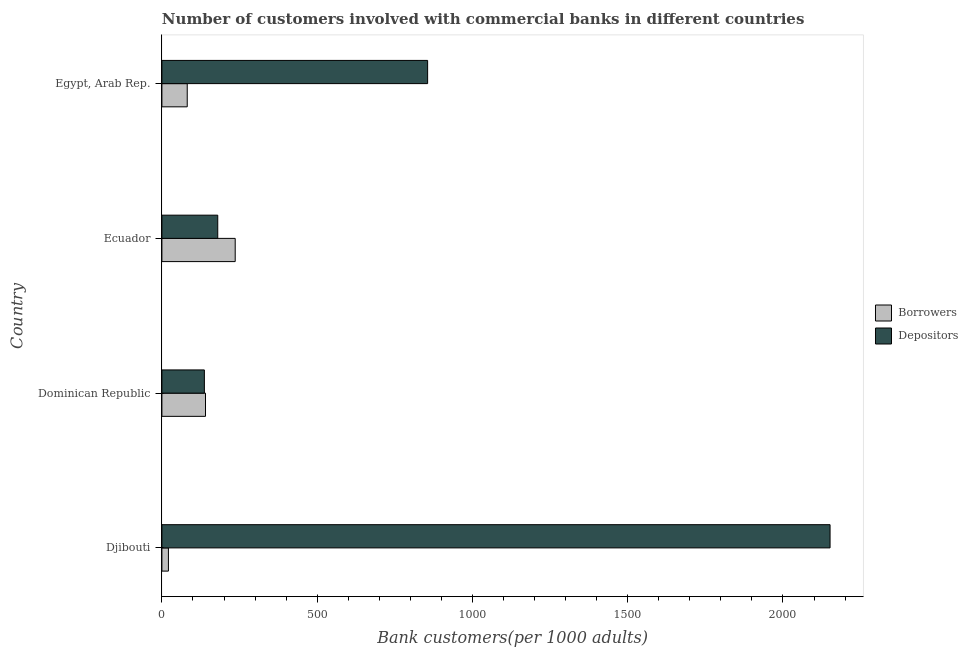How many different coloured bars are there?
Ensure brevity in your answer.  2. How many groups of bars are there?
Ensure brevity in your answer.  4. Are the number of bars per tick equal to the number of legend labels?
Your answer should be compact. Yes. How many bars are there on the 2nd tick from the bottom?
Provide a succinct answer. 2. What is the label of the 4th group of bars from the top?
Provide a short and direct response. Djibouti. What is the number of depositors in Djibouti?
Give a very brief answer. 2151.67. Across all countries, what is the maximum number of borrowers?
Offer a terse response. 236.05. Across all countries, what is the minimum number of depositors?
Your answer should be very brief. 136.78. In which country was the number of depositors maximum?
Your response must be concise. Djibouti. In which country was the number of depositors minimum?
Provide a short and direct response. Dominican Republic. What is the total number of depositors in the graph?
Your response must be concise. 3324.01. What is the difference between the number of depositors in Dominican Republic and that in Egypt, Arab Rep.?
Keep it short and to the point. -718.93. What is the difference between the number of borrowers in Egypt, Arab Rep. and the number of depositors in Djibouti?
Provide a succinct answer. -2070.06. What is the average number of borrowers per country?
Provide a succinct answer. 119.76. What is the difference between the number of depositors and number of borrowers in Dominican Republic?
Your answer should be compact. -3.61. In how many countries, is the number of depositors greater than 1500 ?
Give a very brief answer. 1. What is the ratio of the number of borrowers in Dominican Republic to that in Ecuador?
Give a very brief answer. 0.59. What is the difference between the highest and the second highest number of depositors?
Your answer should be very brief. 1295.95. What is the difference between the highest and the lowest number of depositors?
Offer a terse response. 2014.88. In how many countries, is the number of depositors greater than the average number of depositors taken over all countries?
Provide a succinct answer. 2. Is the sum of the number of borrowers in Djibouti and Ecuador greater than the maximum number of depositors across all countries?
Offer a very short reply. No. What does the 2nd bar from the top in Ecuador represents?
Keep it short and to the point. Borrowers. What does the 1st bar from the bottom in Dominican Republic represents?
Offer a very short reply. Borrowers. How many bars are there?
Provide a succinct answer. 8. Are all the bars in the graph horizontal?
Make the answer very short. Yes. How many countries are there in the graph?
Give a very brief answer. 4. Are the values on the major ticks of X-axis written in scientific E-notation?
Make the answer very short. No. Does the graph contain grids?
Make the answer very short. No. Where does the legend appear in the graph?
Keep it short and to the point. Center right. How many legend labels are there?
Your answer should be compact. 2. What is the title of the graph?
Ensure brevity in your answer.  Number of customers involved with commercial banks in different countries. What is the label or title of the X-axis?
Keep it short and to the point. Bank customers(per 1000 adults). What is the Bank customers(per 1000 adults) in Borrowers in Djibouti?
Give a very brief answer. 20.98. What is the Bank customers(per 1000 adults) of Depositors in Djibouti?
Ensure brevity in your answer.  2151.67. What is the Bank customers(per 1000 adults) of Borrowers in Dominican Republic?
Provide a short and direct response. 140.39. What is the Bank customers(per 1000 adults) in Depositors in Dominican Republic?
Your response must be concise. 136.78. What is the Bank customers(per 1000 adults) in Borrowers in Ecuador?
Your answer should be compact. 236.05. What is the Bank customers(per 1000 adults) in Depositors in Ecuador?
Make the answer very short. 179.84. What is the Bank customers(per 1000 adults) in Borrowers in Egypt, Arab Rep.?
Give a very brief answer. 81.61. What is the Bank customers(per 1000 adults) of Depositors in Egypt, Arab Rep.?
Offer a very short reply. 855.71. Across all countries, what is the maximum Bank customers(per 1000 adults) of Borrowers?
Offer a very short reply. 236.05. Across all countries, what is the maximum Bank customers(per 1000 adults) of Depositors?
Provide a succinct answer. 2151.67. Across all countries, what is the minimum Bank customers(per 1000 adults) in Borrowers?
Offer a terse response. 20.98. Across all countries, what is the minimum Bank customers(per 1000 adults) in Depositors?
Your answer should be compact. 136.78. What is the total Bank customers(per 1000 adults) in Borrowers in the graph?
Your answer should be very brief. 479.03. What is the total Bank customers(per 1000 adults) of Depositors in the graph?
Provide a succinct answer. 3324.01. What is the difference between the Bank customers(per 1000 adults) of Borrowers in Djibouti and that in Dominican Republic?
Your answer should be compact. -119.41. What is the difference between the Bank customers(per 1000 adults) in Depositors in Djibouti and that in Dominican Republic?
Keep it short and to the point. 2014.88. What is the difference between the Bank customers(per 1000 adults) in Borrowers in Djibouti and that in Ecuador?
Ensure brevity in your answer.  -215.07. What is the difference between the Bank customers(per 1000 adults) of Depositors in Djibouti and that in Ecuador?
Your answer should be compact. 1971.83. What is the difference between the Bank customers(per 1000 adults) of Borrowers in Djibouti and that in Egypt, Arab Rep.?
Ensure brevity in your answer.  -60.63. What is the difference between the Bank customers(per 1000 adults) in Depositors in Djibouti and that in Egypt, Arab Rep.?
Keep it short and to the point. 1295.96. What is the difference between the Bank customers(per 1000 adults) in Borrowers in Dominican Republic and that in Ecuador?
Provide a succinct answer. -95.66. What is the difference between the Bank customers(per 1000 adults) of Depositors in Dominican Republic and that in Ecuador?
Your answer should be very brief. -43.06. What is the difference between the Bank customers(per 1000 adults) of Borrowers in Dominican Republic and that in Egypt, Arab Rep.?
Give a very brief answer. 58.78. What is the difference between the Bank customers(per 1000 adults) of Depositors in Dominican Republic and that in Egypt, Arab Rep.?
Your response must be concise. -718.93. What is the difference between the Bank customers(per 1000 adults) in Borrowers in Ecuador and that in Egypt, Arab Rep.?
Offer a very short reply. 154.45. What is the difference between the Bank customers(per 1000 adults) of Depositors in Ecuador and that in Egypt, Arab Rep.?
Provide a succinct answer. -675.87. What is the difference between the Bank customers(per 1000 adults) of Borrowers in Djibouti and the Bank customers(per 1000 adults) of Depositors in Dominican Republic?
Your answer should be compact. -115.81. What is the difference between the Bank customers(per 1000 adults) of Borrowers in Djibouti and the Bank customers(per 1000 adults) of Depositors in Ecuador?
Keep it short and to the point. -158.86. What is the difference between the Bank customers(per 1000 adults) of Borrowers in Djibouti and the Bank customers(per 1000 adults) of Depositors in Egypt, Arab Rep.?
Provide a short and direct response. -834.74. What is the difference between the Bank customers(per 1000 adults) in Borrowers in Dominican Republic and the Bank customers(per 1000 adults) in Depositors in Ecuador?
Offer a very short reply. -39.45. What is the difference between the Bank customers(per 1000 adults) in Borrowers in Dominican Republic and the Bank customers(per 1000 adults) in Depositors in Egypt, Arab Rep.?
Give a very brief answer. -715.32. What is the difference between the Bank customers(per 1000 adults) in Borrowers in Ecuador and the Bank customers(per 1000 adults) in Depositors in Egypt, Arab Rep.?
Offer a very short reply. -619.66. What is the average Bank customers(per 1000 adults) in Borrowers per country?
Offer a terse response. 119.76. What is the average Bank customers(per 1000 adults) of Depositors per country?
Your response must be concise. 831. What is the difference between the Bank customers(per 1000 adults) in Borrowers and Bank customers(per 1000 adults) in Depositors in Djibouti?
Your response must be concise. -2130.69. What is the difference between the Bank customers(per 1000 adults) in Borrowers and Bank customers(per 1000 adults) in Depositors in Dominican Republic?
Your answer should be very brief. 3.61. What is the difference between the Bank customers(per 1000 adults) of Borrowers and Bank customers(per 1000 adults) of Depositors in Ecuador?
Offer a very short reply. 56.21. What is the difference between the Bank customers(per 1000 adults) in Borrowers and Bank customers(per 1000 adults) in Depositors in Egypt, Arab Rep.?
Provide a succinct answer. -774.11. What is the ratio of the Bank customers(per 1000 adults) in Borrowers in Djibouti to that in Dominican Republic?
Offer a very short reply. 0.15. What is the ratio of the Bank customers(per 1000 adults) in Depositors in Djibouti to that in Dominican Republic?
Provide a short and direct response. 15.73. What is the ratio of the Bank customers(per 1000 adults) in Borrowers in Djibouti to that in Ecuador?
Ensure brevity in your answer.  0.09. What is the ratio of the Bank customers(per 1000 adults) of Depositors in Djibouti to that in Ecuador?
Provide a short and direct response. 11.96. What is the ratio of the Bank customers(per 1000 adults) in Borrowers in Djibouti to that in Egypt, Arab Rep.?
Your answer should be compact. 0.26. What is the ratio of the Bank customers(per 1000 adults) of Depositors in Djibouti to that in Egypt, Arab Rep.?
Make the answer very short. 2.51. What is the ratio of the Bank customers(per 1000 adults) in Borrowers in Dominican Republic to that in Ecuador?
Your answer should be very brief. 0.59. What is the ratio of the Bank customers(per 1000 adults) in Depositors in Dominican Republic to that in Ecuador?
Offer a very short reply. 0.76. What is the ratio of the Bank customers(per 1000 adults) in Borrowers in Dominican Republic to that in Egypt, Arab Rep.?
Make the answer very short. 1.72. What is the ratio of the Bank customers(per 1000 adults) in Depositors in Dominican Republic to that in Egypt, Arab Rep.?
Your response must be concise. 0.16. What is the ratio of the Bank customers(per 1000 adults) in Borrowers in Ecuador to that in Egypt, Arab Rep.?
Ensure brevity in your answer.  2.89. What is the ratio of the Bank customers(per 1000 adults) of Depositors in Ecuador to that in Egypt, Arab Rep.?
Your answer should be very brief. 0.21. What is the difference between the highest and the second highest Bank customers(per 1000 adults) of Borrowers?
Your answer should be very brief. 95.66. What is the difference between the highest and the second highest Bank customers(per 1000 adults) in Depositors?
Make the answer very short. 1295.96. What is the difference between the highest and the lowest Bank customers(per 1000 adults) of Borrowers?
Provide a succinct answer. 215.07. What is the difference between the highest and the lowest Bank customers(per 1000 adults) of Depositors?
Make the answer very short. 2014.88. 